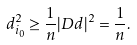<formula> <loc_0><loc_0><loc_500><loc_500>d _ { i _ { 0 } } ^ { 2 } \geq \frac { 1 } { n } | D d | ^ { 2 } = \frac { 1 } { n } .</formula> 